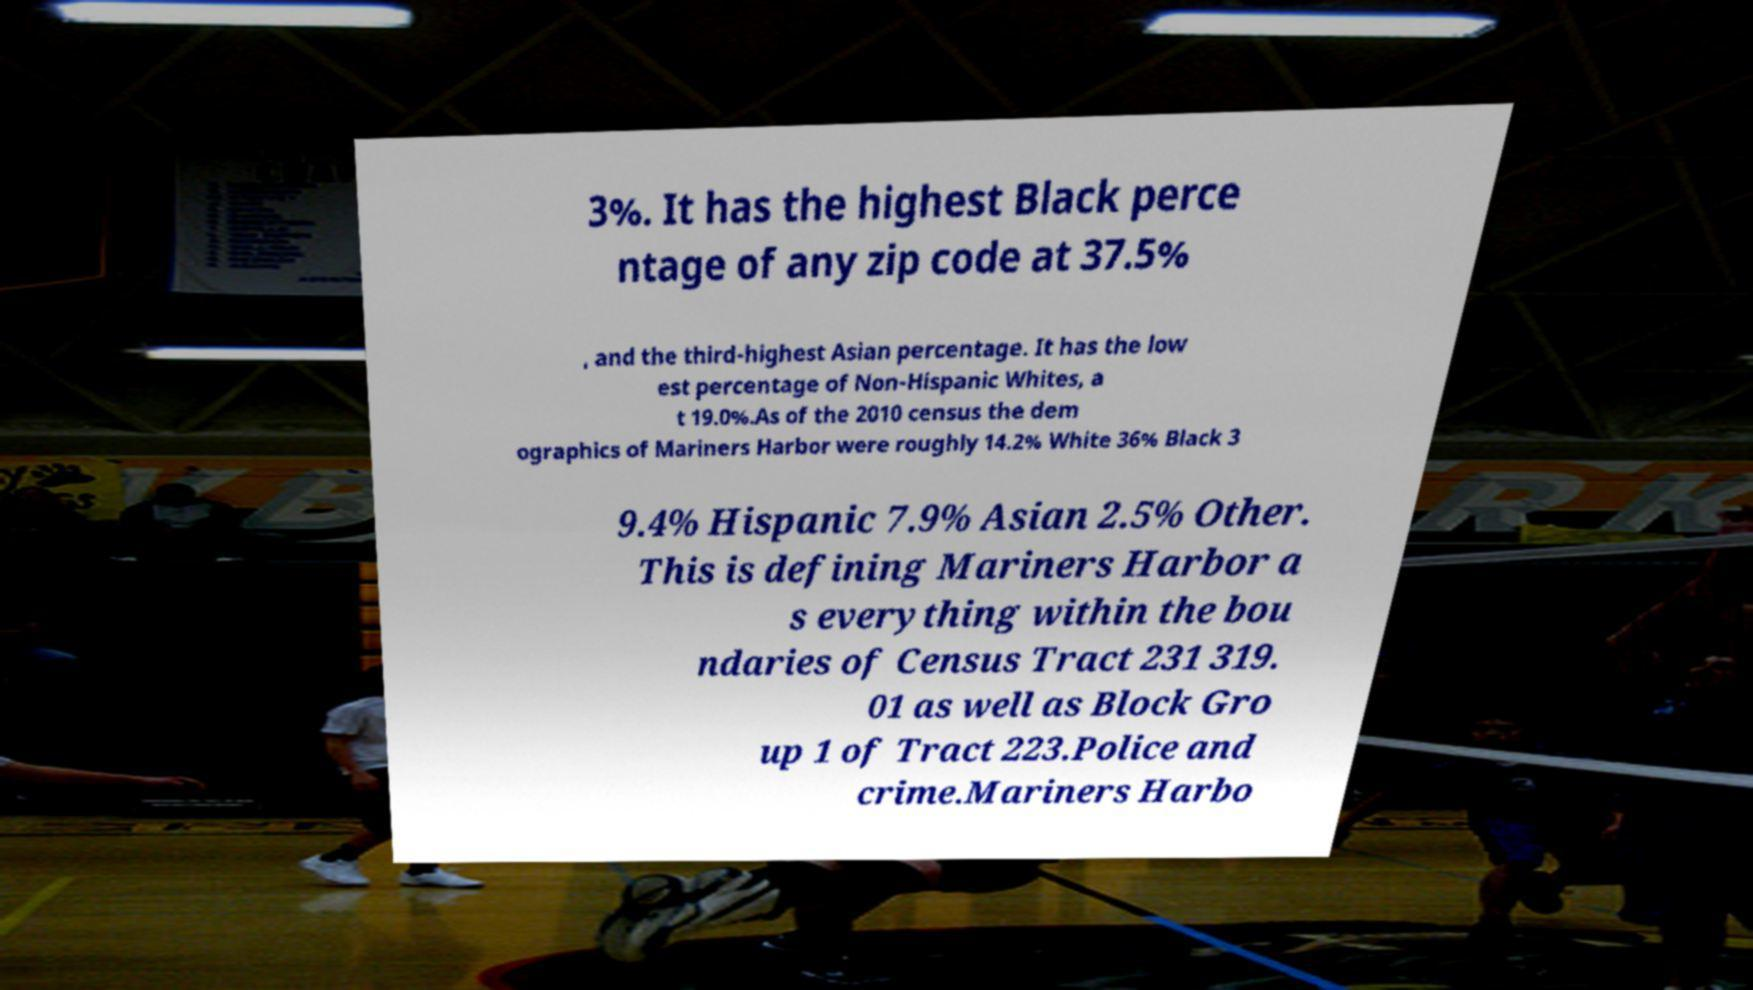Can you accurately transcribe the text from the provided image for me? 3%. It has the highest Black perce ntage of any zip code at 37.5% , and the third-highest Asian percentage. It has the low est percentage of Non-Hispanic Whites, a t 19.0%.As of the 2010 census the dem ographics of Mariners Harbor were roughly 14.2% White 36% Black 3 9.4% Hispanic 7.9% Asian 2.5% Other. This is defining Mariners Harbor a s everything within the bou ndaries of Census Tract 231 319. 01 as well as Block Gro up 1 of Tract 223.Police and crime.Mariners Harbo 